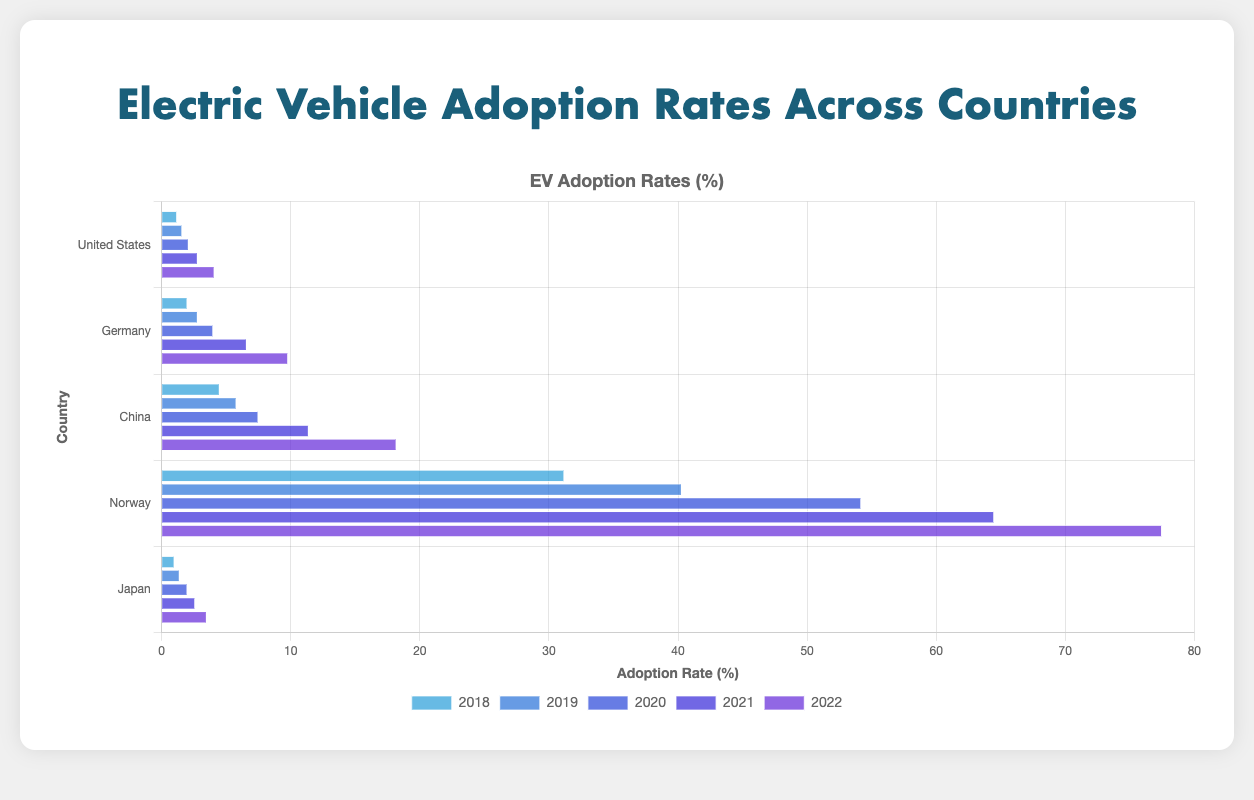Which country had the highest EV adoption rate in 2022? The highest EV adoption rate in 2022 can be identified by looking at the longest bar for that year in the grouped bars. Norway has the longest bar in 2022.
Answer: Norway What was the difference in EV adoption rate between the United States and China in 2022? The EV adoption rate of the United States in 2022 is 4.1%, and it is 18.2% for China in the same year. The difference is calculated as 18.2 - 4.1 = 14.1%.
Answer: 14.1% How did the EV adoption rate in Japan change from 2018 to 2022? To determine the change, subtract the 2018 adoption rate from the 2022 rate for Japan. The 2022 rate is 3.5%, and the 2018 rate is 1.0%, so the difference is 3.5 - 1.0 = 2.5%.
Answer: Increased by 2.5% Which country saw the largest increase in EV adoption rate from 2018 to 2022? Calculate the increase for each country from 2018 to 2022. For the United States, it’s 4.1 - 1.2 = 2.9%. For Germany, it’s 9.8 - 2.0 = 7.8%. For China, it’s 18.2 - 4.5 = 13.7%. For Norway, it’s 77.5 - 31.2 = 46.3%. For Japan, it’s 3.5 - 1.0 = 2.5%. Norway has the largest increase of 46.3%.
Answer: Norway What is the average EV adoption rate for Germany from 2018 to 2022? Calculate the average of the adoption rates for Germany across the five years: (2.0 + 2.8 + 4.0 + 6.6 + 9.8) / 5 = 25.2 / 5 = 5.04%.
Answer: 5.04% By how much did the EV adoption rate in Norway exceed that in Germany in 2020? The EV adoption rate in Norway in 2020 is 54.2%, and it is 4.0% for Germany. Subtract the German rate from the Norwegian rate: 54.2 - 4.0 = 50.2%.
Answer: 50.2% Comparing the EV adoption rates in 2019, which country had the smallest increase compared to 2018? Calculate the increase from 2018 to 2019 for each country. For the United States, 1.6 - 1.2 = 0.4%. For Germany, 2.8 - 2.0 = 0.8%. For China, 5.8 - 4.5 = 1.3%. For Norway, 40.3 - 31.2 = 9.1%. For Japan, 1.4 - 1.0 = 0.4%. Both the United States and Japan had the smallest increase of 0.4%.
Answer: United States and Japan 